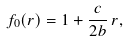Convert formula to latex. <formula><loc_0><loc_0><loc_500><loc_500>f _ { 0 } ( r ) = 1 + \frac { c } { 2 b } \, r ,</formula> 